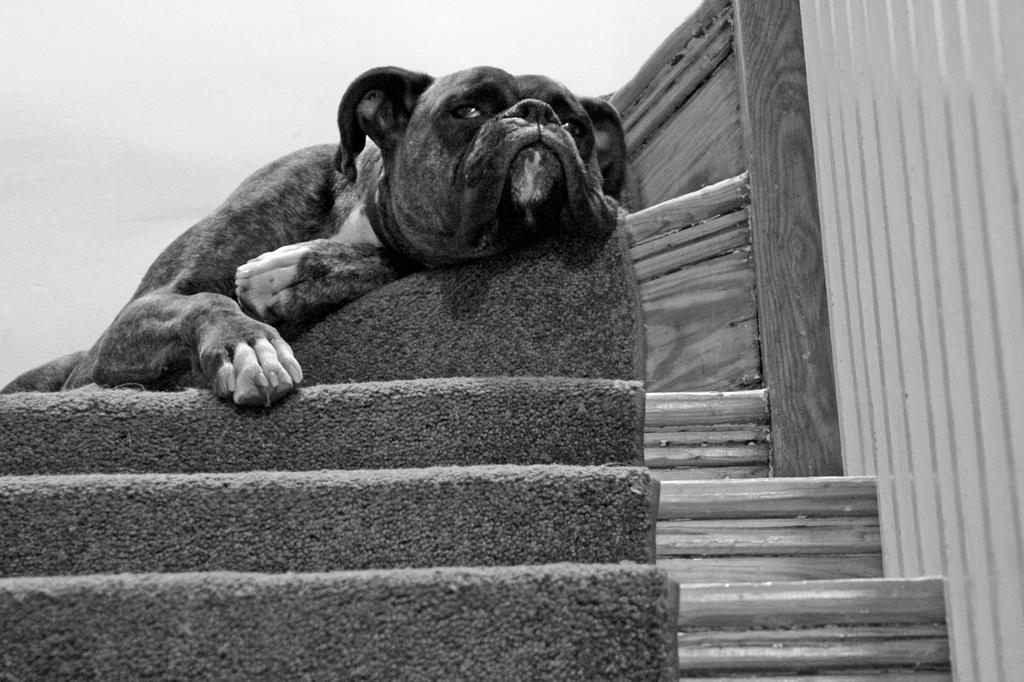What is the color scheme of the image? The image is black and white. What animal can be seen in the image? There is a dog in the image. What is the dog doing in the image? The dog is sleeping. Where is the dog located in the image? The dog is on a staircase. What is the name of the dog in the image? The provided facts do not mention the name of the dog, so we cannot determine its name from the image. What season is depicted in the image? The image is black and white, so it is not possible to determine the season based on the color scheme. 